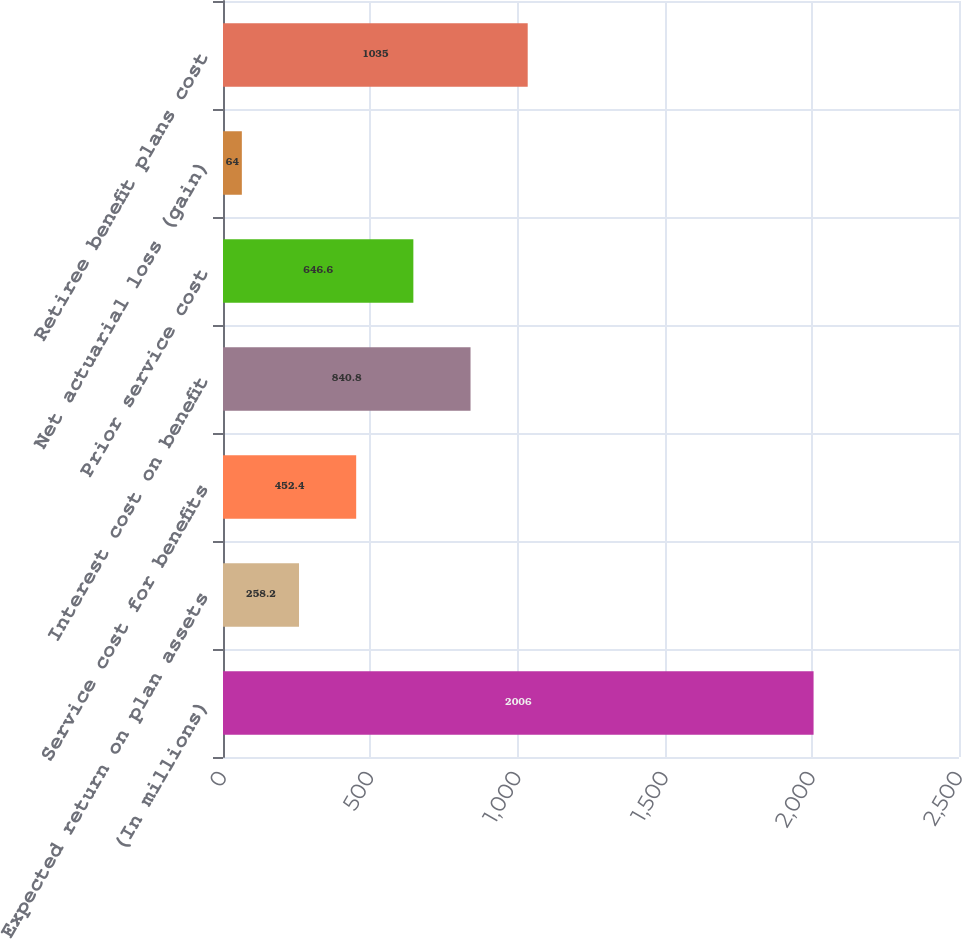Convert chart. <chart><loc_0><loc_0><loc_500><loc_500><bar_chart><fcel>(In millions)<fcel>Expected return on plan assets<fcel>Service cost for benefits<fcel>Interest cost on benefit<fcel>Prior service cost<fcel>Net actuarial loss (gain)<fcel>Retiree benefit plans cost<nl><fcel>2006<fcel>258.2<fcel>452.4<fcel>840.8<fcel>646.6<fcel>64<fcel>1035<nl></chart> 